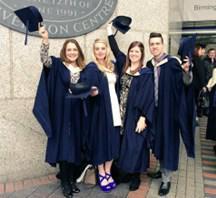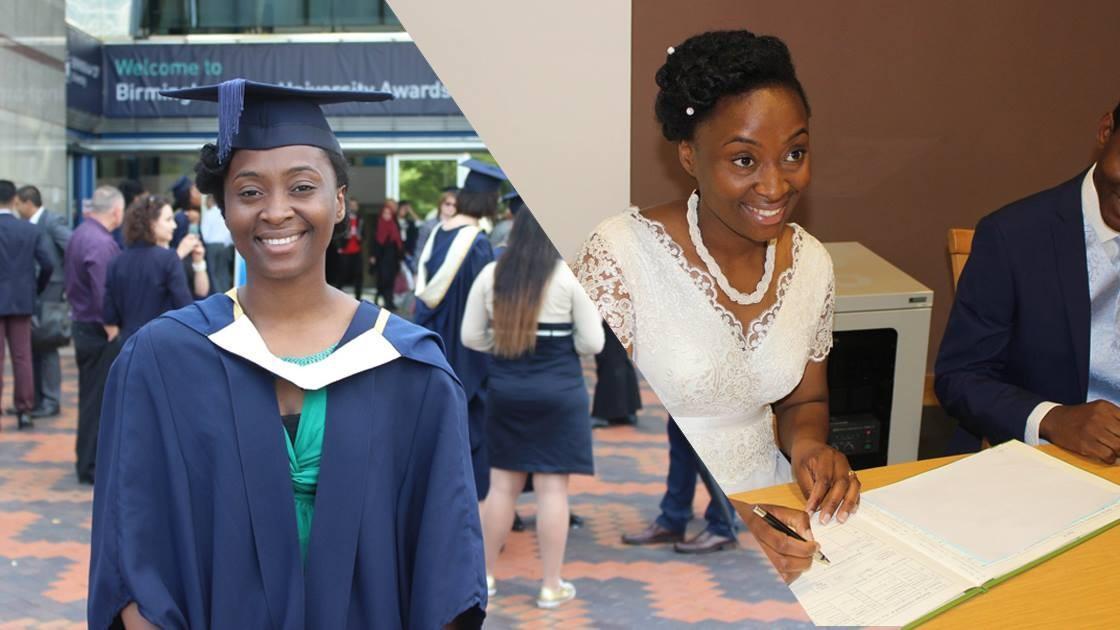The first image is the image on the left, the second image is the image on the right. Analyze the images presented: Is the assertion "The graduates in the right image are wearing blue gowns." valid? Answer yes or no. Yes. The first image is the image on the left, the second image is the image on the right. For the images shown, is this caption "One image shows two forward-facing dark-haired female graduates in the foreground, wearing matching hats and robes with a white V at the collar." true? Answer yes or no. No. 